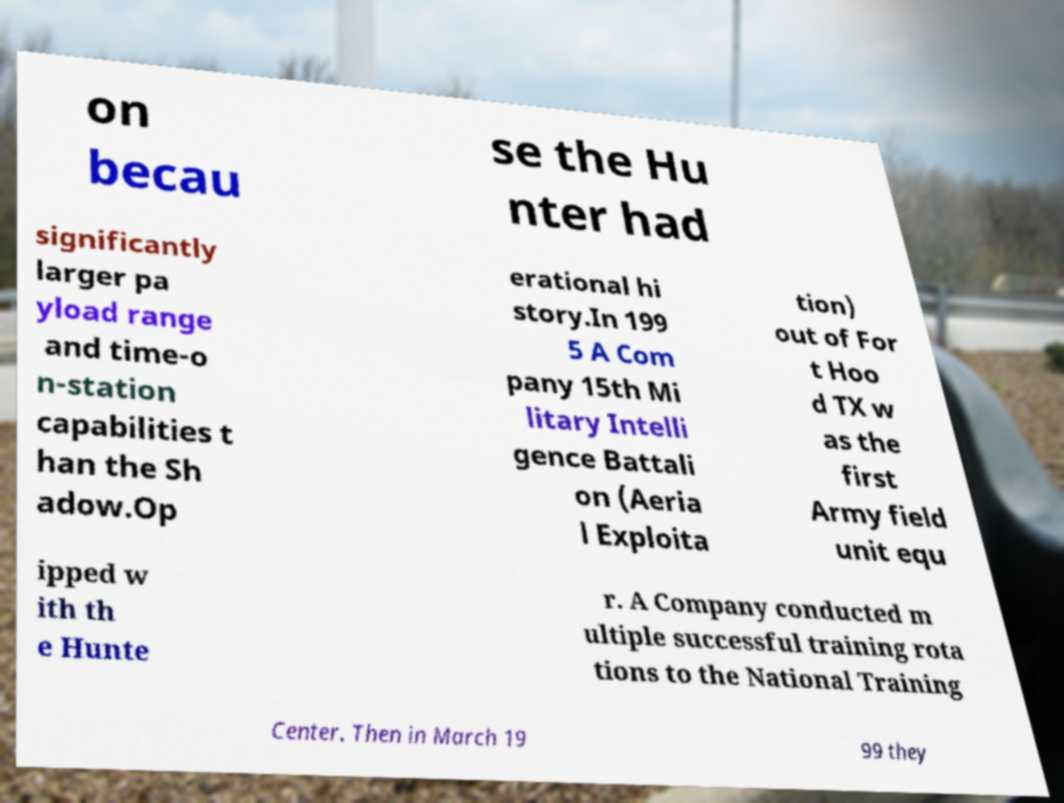For documentation purposes, I need the text within this image transcribed. Could you provide that? on becau se the Hu nter had significantly larger pa yload range and time-o n-station capabilities t han the Sh adow.Op erational hi story.In 199 5 A Com pany 15th Mi litary Intelli gence Battali on (Aeria l Exploita tion) out of For t Hoo d TX w as the first Army field unit equ ipped w ith th e Hunte r. A Company conducted m ultiple successful training rota tions to the National Training Center. Then in March 19 99 they 